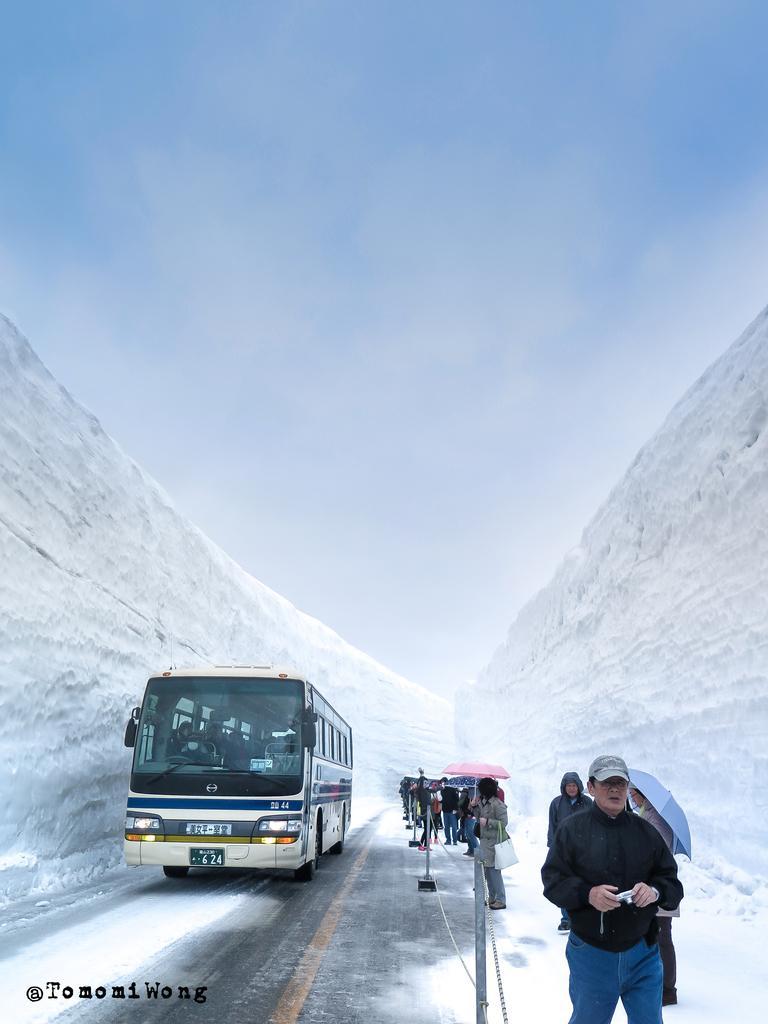Could you give a brief overview of what you see in this image? In this image I can see a road in the centre and on it I can see a bus, few poles, a chain and I can also see number of people are standing. I can see few of them are holding umbrellas and I can see most of them are wearing jackets. In the front I can see one of them is wearing a cap and I can see he is holding a camera. On the both sides of the road I can see snow walls and on the bottom left side of this image I can see a watermark. I can also see clouds and the sky in the background. 